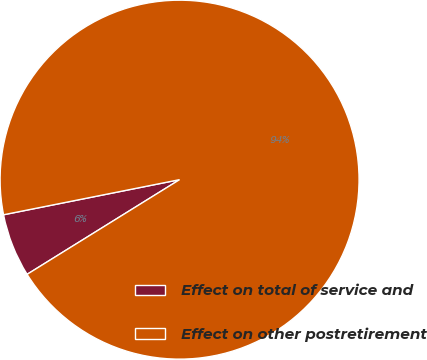<chart> <loc_0><loc_0><loc_500><loc_500><pie_chart><fcel>Effect on total of service and<fcel>Effect on other postretirement<nl><fcel>5.71%<fcel>94.29%<nl></chart> 